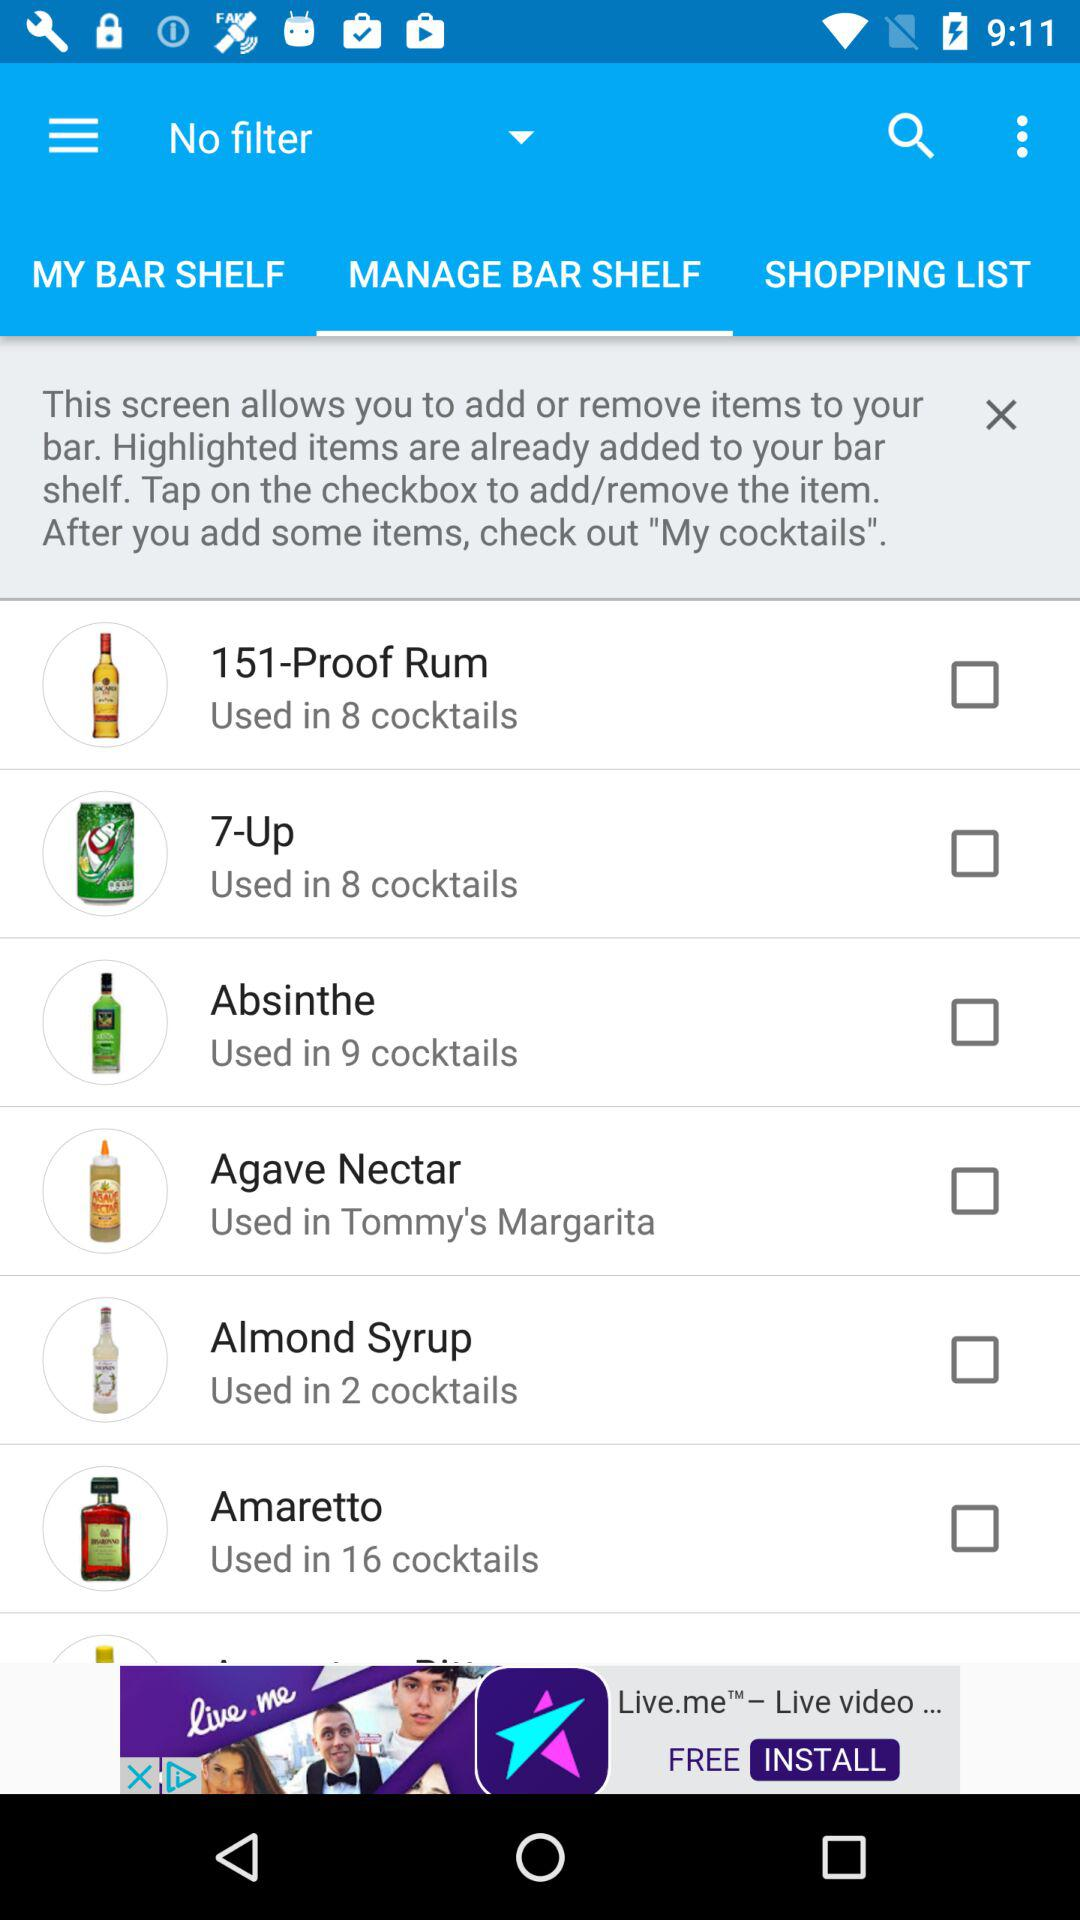How many cocktails use the ingredient 'Amaretto'?
Answer the question using a single word or phrase. 16 